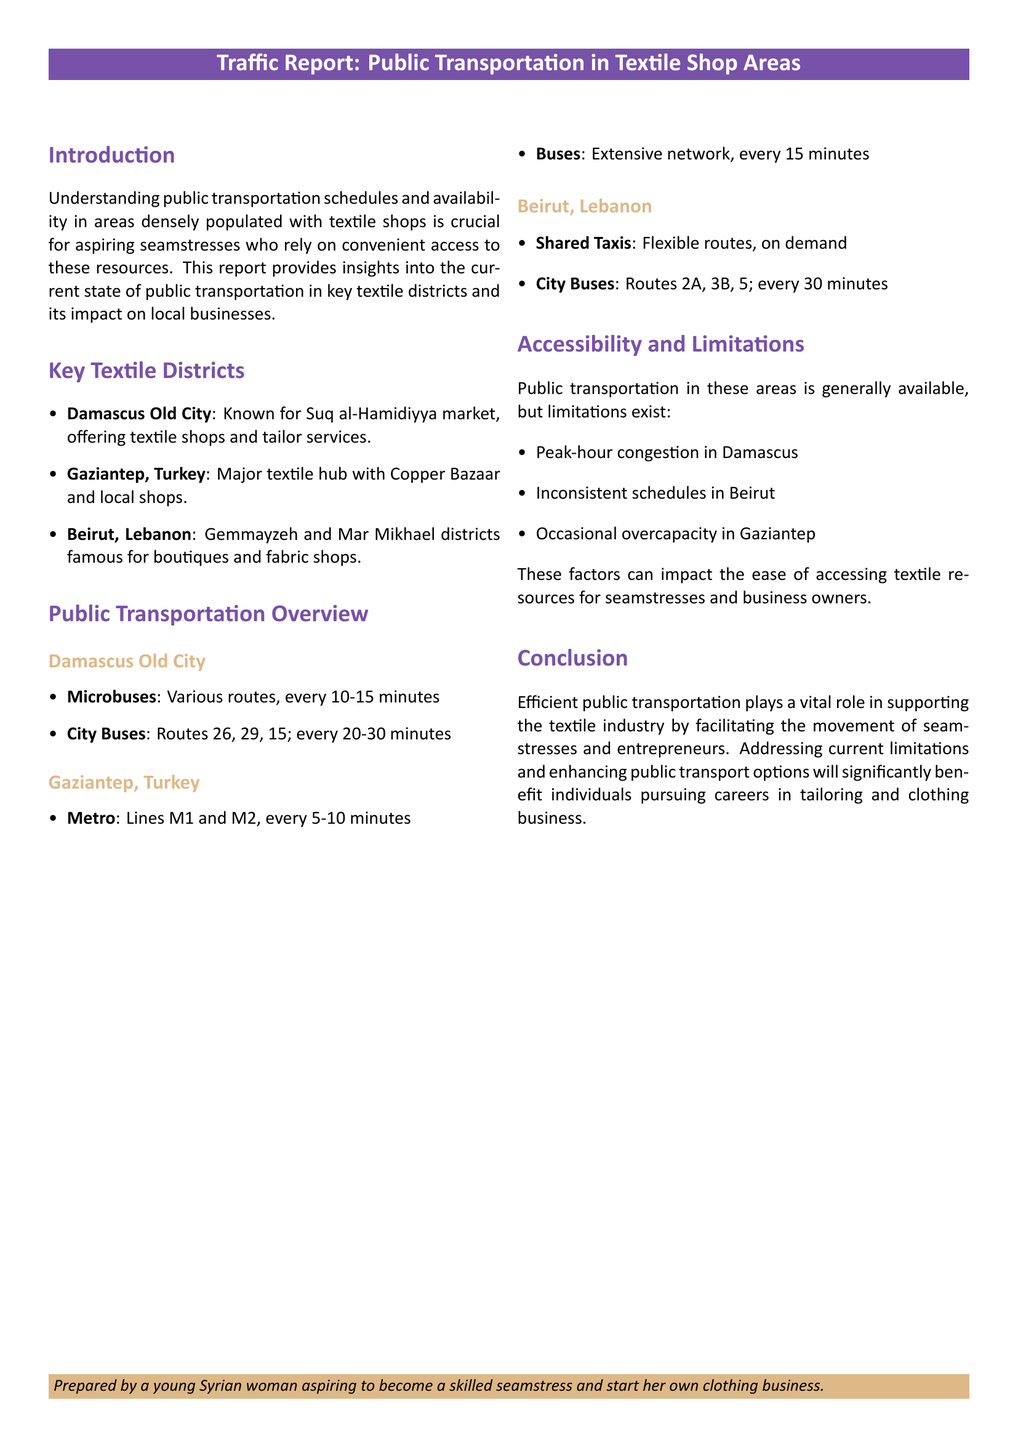what are the key textile districts mentioned? The document lists three key textile districts: Damascus Old City, Gaziantep, and Beirut.
Answer: Damascus Old City, Gaziantep, Beirut how often do microbuses run in Damascus Old City? According to the report, microbuses in Damascus Old City operate every 10-15 minutes.
Answer: every 10-15 minutes which transportation method in Gaziantep has the shortest interval? The report indicates that the metro lines M1 and M2 in Gaziantep run every 5-10 minutes, which is the shortest interval.
Answer: metro what is a limitation mentioned for public transportation in Beirut? The document notes that there are inconsistent schedules in Beirut as a limitation of public transportation.
Answer: inconsistent schedules how many bus routes are mentioned for the City Buses in Beirut? The report states that there are three specific bus routes mentioned for City Buses in Beirut: 2A, 3B, and 5.
Answer: three routes how does public transportation impact seamstresses and entrepreneurs? The conclusion highlights the vital role of efficient public transportation in supporting the textile industry for seamstresses and entrepreneurs.
Answer: supports the textile industry which district is known for Suq al-Hamidiyya market? The report mentions that the Damascus Old City is known for the Suq al-Hamidiyya market.
Answer: Damascus Old City what is the purpose of this traffic report? The purpose of this traffic report is to provide insights into public transportation schedules and availability in textile shop areas.
Answer: provide insights into public transportation 